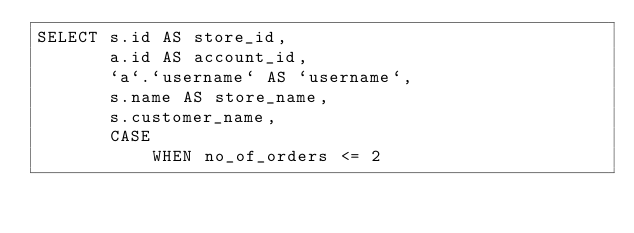<code> <loc_0><loc_0><loc_500><loc_500><_SQL_>SELECT s.id AS store_id,
       a.id AS account_id,
       `a`.`username` AS `username`,
       s.name AS store_name,
       s.customer_name,
       CASE
           WHEN no_of_orders <= 2</code> 